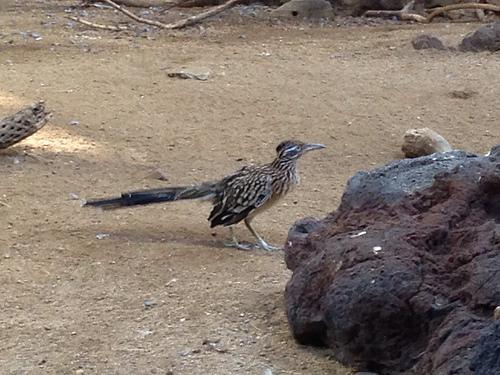Question: what kind of animal is there?
Choices:
A. A fish.
B. A cat.
C. A dog.
D. A bird.
Answer with the letter. Answer: D Question: what wooden objects are in the background?
Choices:
A. Logs.
B. Trees.
C. Branches.
D. Bench.
Answer with the letter. Answer: C Question: where was the picture taken?
Choices:
A. Near flowers.
B. Near pictures.
C. Near trees.
D. Near rocks.
Answer with the letter. Answer: D 